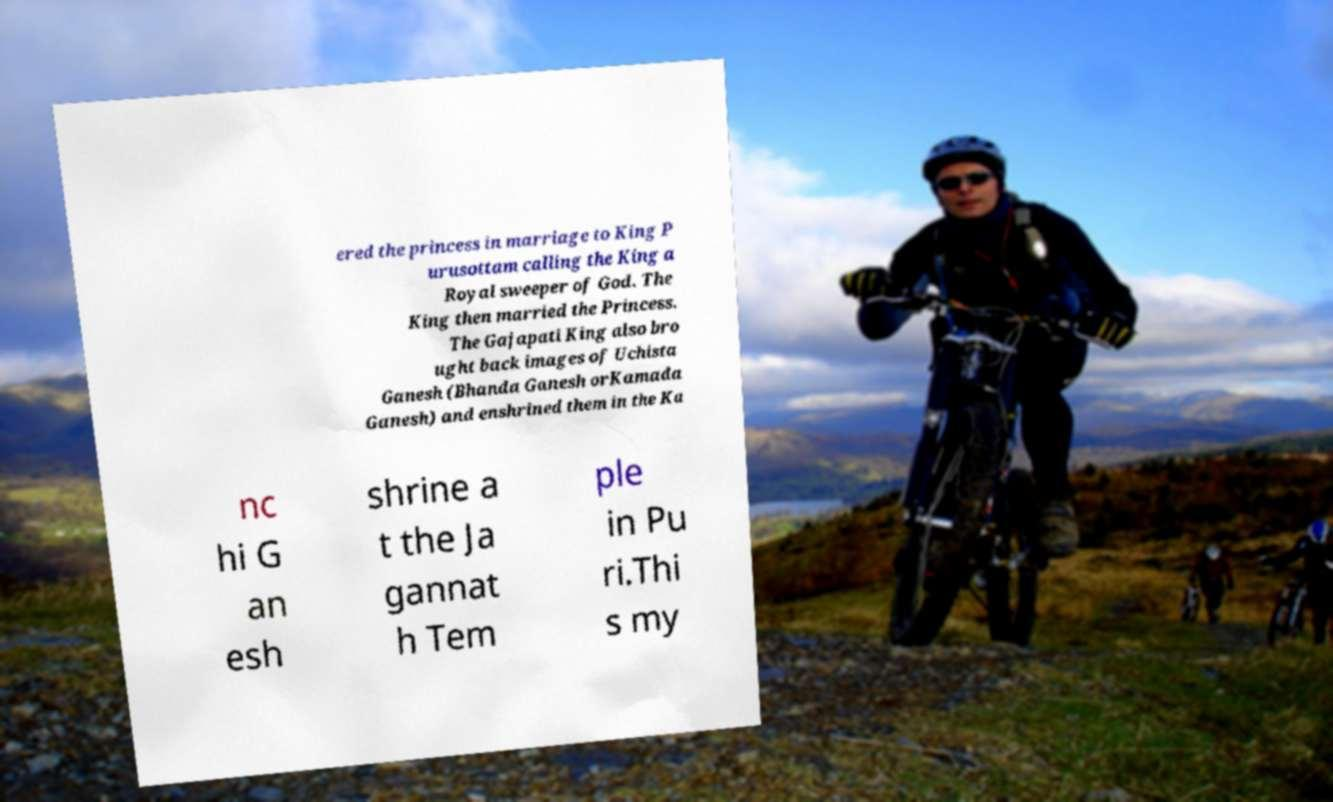Could you extract and type out the text from this image? ered the princess in marriage to King P urusottam calling the King a Royal sweeper of God. The King then married the Princess. The Gajapati King also bro ught back images of Uchista Ganesh (Bhanda Ganesh orKamada Ganesh) and enshrined them in the Ka nc hi G an esh shrine a t the Ja gannat h Tem ple in Pu ri.Thi s my 